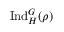<formula> <loc_0><loc_0><loc_500><loc_500>{ I n d } _ { H } ^ { G } ( \rho )</formula> 